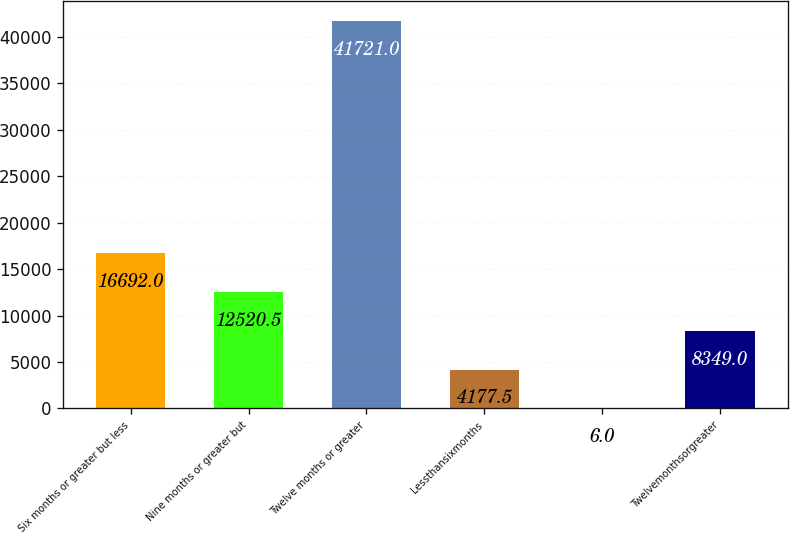Convert chart. <chart><loc_0><loc_0><loc_500><loc_500><bar_chart><fcel>Six months or greater but less<fcel>Nine months or greater but<fcel>Twelve months or greater<fcel>Lessthansixmonths<fcel>Unnamed: 4<fcel>Twelvemonthsorgreater<nl><fcel>16692<fcel>12520.5<fcel>41721<fcel>4177.5<fcel>6<fcel>8349<nl></chart> 